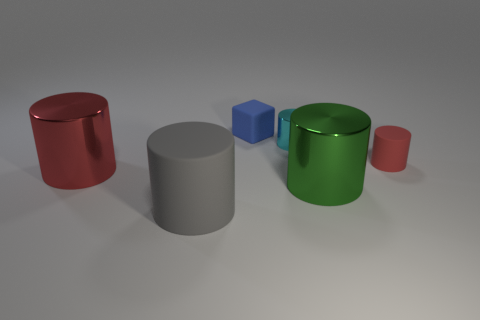Are the small cyan cylinder and the red cylinder to the left of the gray rubber cylinder made of the same material?
Your response must be concise. Yes. The gray thing that is the same material as the small blue cube is what size?
Make the answer very short. Large. Is the number of objects that are to the right of the tiny cyan metal thing greater than the number of red metal cylinders behind the rubber cube?
Provide a succinct answer. Yes. Is there a small blue thing that has the same shape as the cyan object?
Make the answer very short. No. Do the object that is in front of the green shiny cylinder and the blue matte cube have the same size?
Make the answer very short. No. Are any cyan matte blocks visible?
Your answer should be very brief. No. What number of things are either red cylinders that are on the right side of the cyan cylinder or large things?
Your response must be concise. 4. There is a big rubber object; is its color the same as the small matte thing behind the tiny red object?
Your answer should be compact. No. Is there a cyan matte thing of the same size as the cyan cylinder?
Offer a terse response. No. What is the red cylinder to the right of the tiny rubber thing on the left side of the tiny red thing made of?
Your response must be concise. Rubber. 